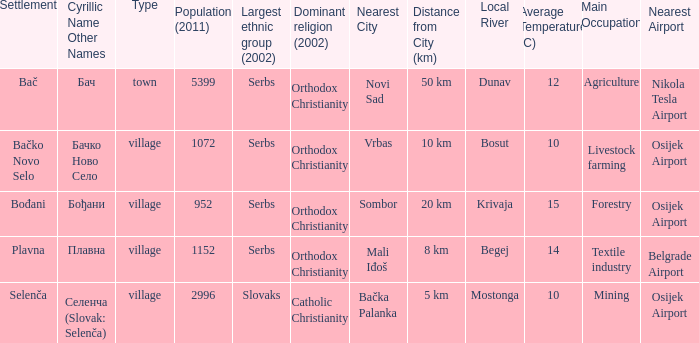What is the ethnic majority in the only town? Serbs. 